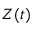<formula> <loc_0><loc_0><loc_500><loc_500>Z ( t )</formula> 